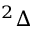Convert formula to latex. <formula><loc_0><loc_0><loc_500><loc_500>^ { 2 } \Delta</formula> 